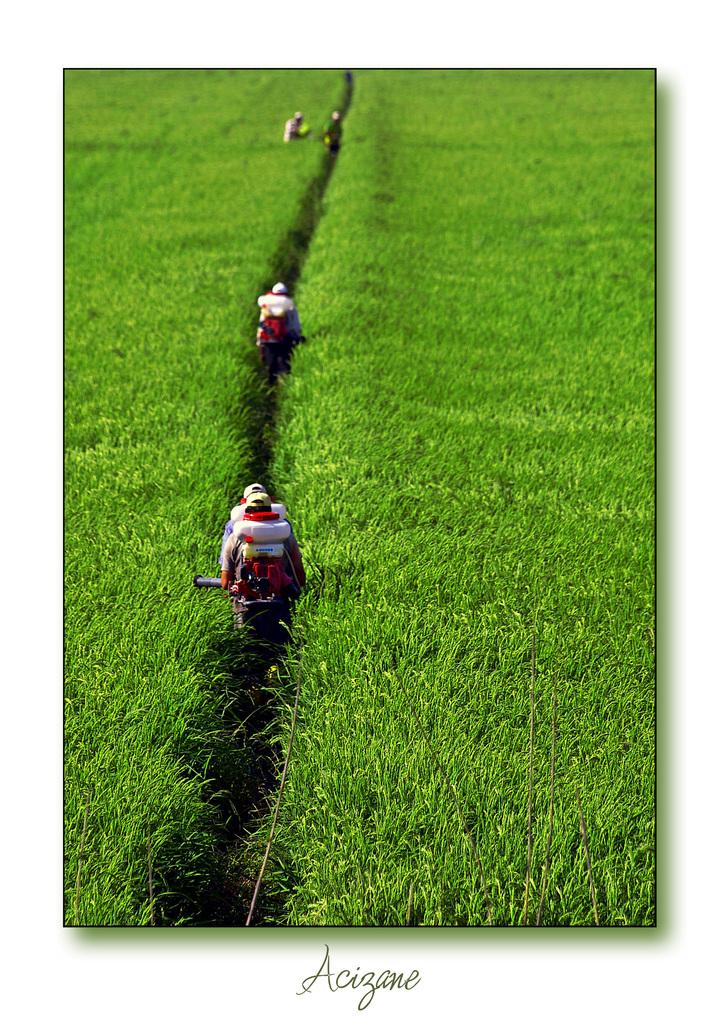What is happening in the center of the image? There are persons standing in the center of the image. What type of surface is under the persons' feet? There is grass on the ground in the image. Is there any text visible in the image? Yes, there is some text written on the image. What type of railway can be seen in the image? There is no railway present in the image. How many sticks are being held by the persons in the image? There is no mention of sticks in the image, so we cannot determine how many might be held by the persons. 